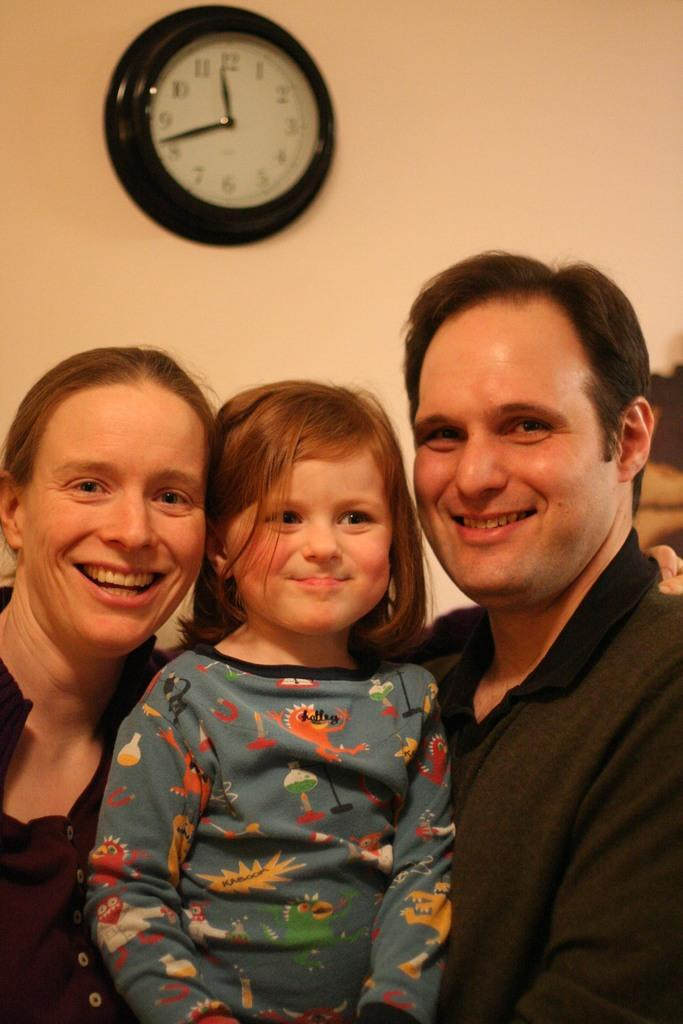<image>
Provide a brief description of the given image. Two adult and a child pose for a photo at 11:43. 